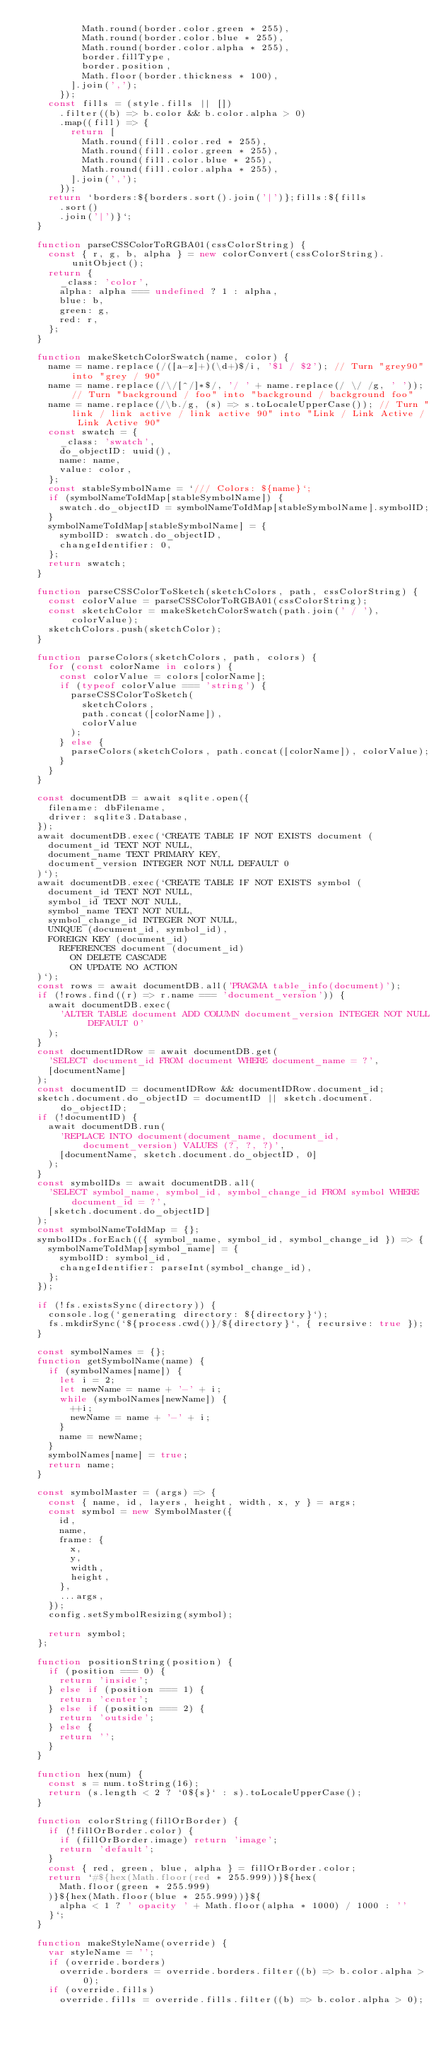<code> <loc_0><loc_0><loc_500><loc_500><_JavaScript_>          Math.round(border.color.green * 255),
          Math.round(border.color.blue * 255),
          Math.round(border.color.alpha * 255),
          border.fillType,
          border.position,
          Math.floor(border.thickness * 100),
        ].join(',');
      });
    const fills = (style.fills || [])
      .filter((b) => b.color && b.color.alpha > 0)
      .map((fill) => {
        return [
          Math.round(fill.color.red * 255),
          Math.round(fill.color.green * 255),
          Math.round(fill.color.blue * 255),
          Math.round(fill.color.alpha * 255),
        ].join(',');
      });
    return `borders:${borders.sort().join('|')};fills:${fills
      .sort()
      .join('|')}`;
  }

  function parseCSSColorToRGBA01(cssColorString) {
    const { r, g, b, alpha } = new colorConvert(cssColorString).unitObject();
    return {
      _class: 'color',
      alpha: alpha === undefined ? 1 : alpha,
      blue: b,
      green: g,
      red: r,
    };
  }

  function makeSketchColorSwatch(name, color) {
    name = name.replace(/([a-z]+)(\d+)$/i, '$1 / $2'); // Turn "grey90" into "grey / 90"
    name = name.replace(/\/[^/]*$/, '/ ' + name.replace(/ \/ /g, ' ')); // Turn "background / foo" into "background / background foo"
    name = name.replace(/\b./g, (s) => s.toLocaleUpperCase()); // Turn "link / link active / link active 90" into "Link / Link Active / Link Active 90"
    const swatch = {
      _class: 'swatch',
      do_objectID: uuid(),
      name: name,
      value: color,
    };
    const stableSymbolName = `/// Colors: ${name}`;
    if (symbolNameToIdMap[stableSymbolName]) {
      swatch.do_objectID = symbolNameToIdMap[stableSymbolName].symbolID;
    }
    symbolNameToIdMap[stableSymbolName] = {
      symbolID: swatch.do_objectID,
      changeIdentifier: 0,
    };
    return swatch;
  }

  function parseCSSColorToSketch(sketchColors, path, cssColorString) {
    const colorValue = parseCSSColorToRGBA01(cssColorString);
    const sketchColor = makeSketchColorSwatch(path.join(' / '), colorValue);
    sketchColors.push(sketchColor);
  }

  function parseColors(sketchColors, path, colors) {
    for (const colorName in colors) {
      const colorValue = colors[colorName];
      if (typeof colorValue === 'string') {
        parseCSSColorToSketch(
          sketchColors,
          path.concat([colorName]),
          colorValue
        );
      } else {
        parseColors(sketchColors, path.concat([colorName]), colorValue);
      }
    }
  }

  const documentDB = await sqlite.open({
    filename: dbFilename,
    driver: sqlite3.Database,
  });
  await documentDB.exec(`CREATE TABLE IF NOT EXISTS document (
    document_id TEXT NOT NULL,
    document_name TEXT PRIMARY KEY,
    document_version INTEGER NOT NULL DEFAULT 0
  )`);
  await documentDB.exec(`CREATE TABLE IF NOT EXISTS symbol (
    document_id TEXT NOT NULL,
    symbol_id TEXT NOT NULL,
    symbol_name TEXT NOT NULL,
    symbol_change_id INTEGER NOT NULL,
    UNIQUE (document_id, symbol_id),
    FOREIGN KEY (document_id)
      REFERENCES document (document_id)
        ON DELETE CASCADE
        ON UPDATE NO ACTION
  )`);
  const rows = await documentDB.all('PRAGMA table_info(document)');
  if (!rows.find((r) => r.name === 'document_version')) {
    await documentDB.exec(
      'ALTER TABLE document ADD COLUMN document_version INTEGER NOT NULL DEFAULT 0'
    );
  }
  const documentIDRow = await documentDB.get(
    'SELECT document_id FROM document WHERE document_name = ?',
    [documentName]
  );
  const documentID = documentIDRow && documentIDRow.document_id;
  sketch.document.do_objectID = documentID || sketch.document.do_objectID;
  if (!documentID) {
    await documentDB.run(
      'REPLACE INTO document(document_name, document_id, document_version) VALUES (?, ?, ?)',
      [documentName, sketch.document.do_objectID, 0]
    );
  }
  const symbolIDs = await documentDB.all(
    'SELECT symbol_name, symbol_id, symbol_change_id FROM symbol WHERE document_id = ?',
    [sketch.document.do_objectID]
  );
  const symbolNameToIdMap = {};
  symbolIDs.forEach(({ symbol_name, symbol_id, symbol_change_id }) => {
    symbolNameToIdMap[symbol_name] = {
      symbolID: symbol_id,
      changeIdentifier: parseInt(symbol_change_id),
    };
  });

  if (!fs.existsSync(directory)) {
    console.log(`generating directory: ${directory}`);
    fs.mkdirSync(`${process.cwd()}/${directory}`, { recursive: true });
  }

  const symbolNames = {};
  function getSymbolName(name) {
    if (symbolNames[name]) {
      let i = 2;
      let newName = name + '-' + i;
      while (symbolNames[newName]) {
        ++i;
        newName = name + '-' + i;
      }
      name = newName;
    }
    symbolNames[name] = true;
    return name;
  }

  const symbolMaster = (args) => {
    const { name, id, layers, height, width, x, y } = args;
    const symbol = new SymbolMaster({
      id,
      name,
      frame: {
        x,
        y,
        width,
        height,
      },
      ...args,
    });
    config.setSymbolResizing(symbol);

    return symbol;
  };

  function positionString(position) {
    if (position === 0) {
      return 'inside';
    } else if (position === 1) {
      return 'center';
    } else if (position === 2) {
      return 'outside';
    } else {
      return '';
    }
  }

  function hex(num) {
    const s = num.toString(16);
    return (s.length < 2 ? `0${s}` : s).toLocaleUpperCase();
  }

  function colorString(fillOrBorder) {
    if (!fillOrBorder.color) {
      if (fillOrBorder.image) return 'image';
      return 'default';
    }
    const { red, green, blue, alpha } = fillOrBorder.color;
    return `#${hex(Math.floor(red * 255.999))}${hex(
      Math.floor(green * 255.999)
    )}${hex(Math.floor(blue * 255.999))}${
      alpha < 1 ? ' opacity ' + Math.floor(alpha * 1000) / 1000 : ''
    }`;
  }

  function makeStyleName(override) {
    var styleName = '';
    if (override.borders)
      override.borders = override.borders.filter((b) => b.color.alpha > 0);
    if (override.fills)
      override.fills = override.fills.filter((b) => b.color.alpha > 0);</code> 